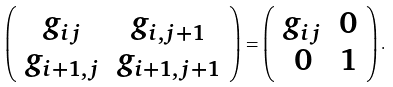Convert formula to latex. <formula><loc_0><loc_0><loc_500><loc_500>\left ( \begin{array} { c c } g _ { i j } & g _ { i , j + 1 } \\ g _ { i + 1 , j } & g _ { i + 1 , j + 1 } \end{array} \right ) = \left ( \begin{array} { c c } g _ { i j } & 0 \\ 0 & 1 \end{array} \right ) .</formula> 